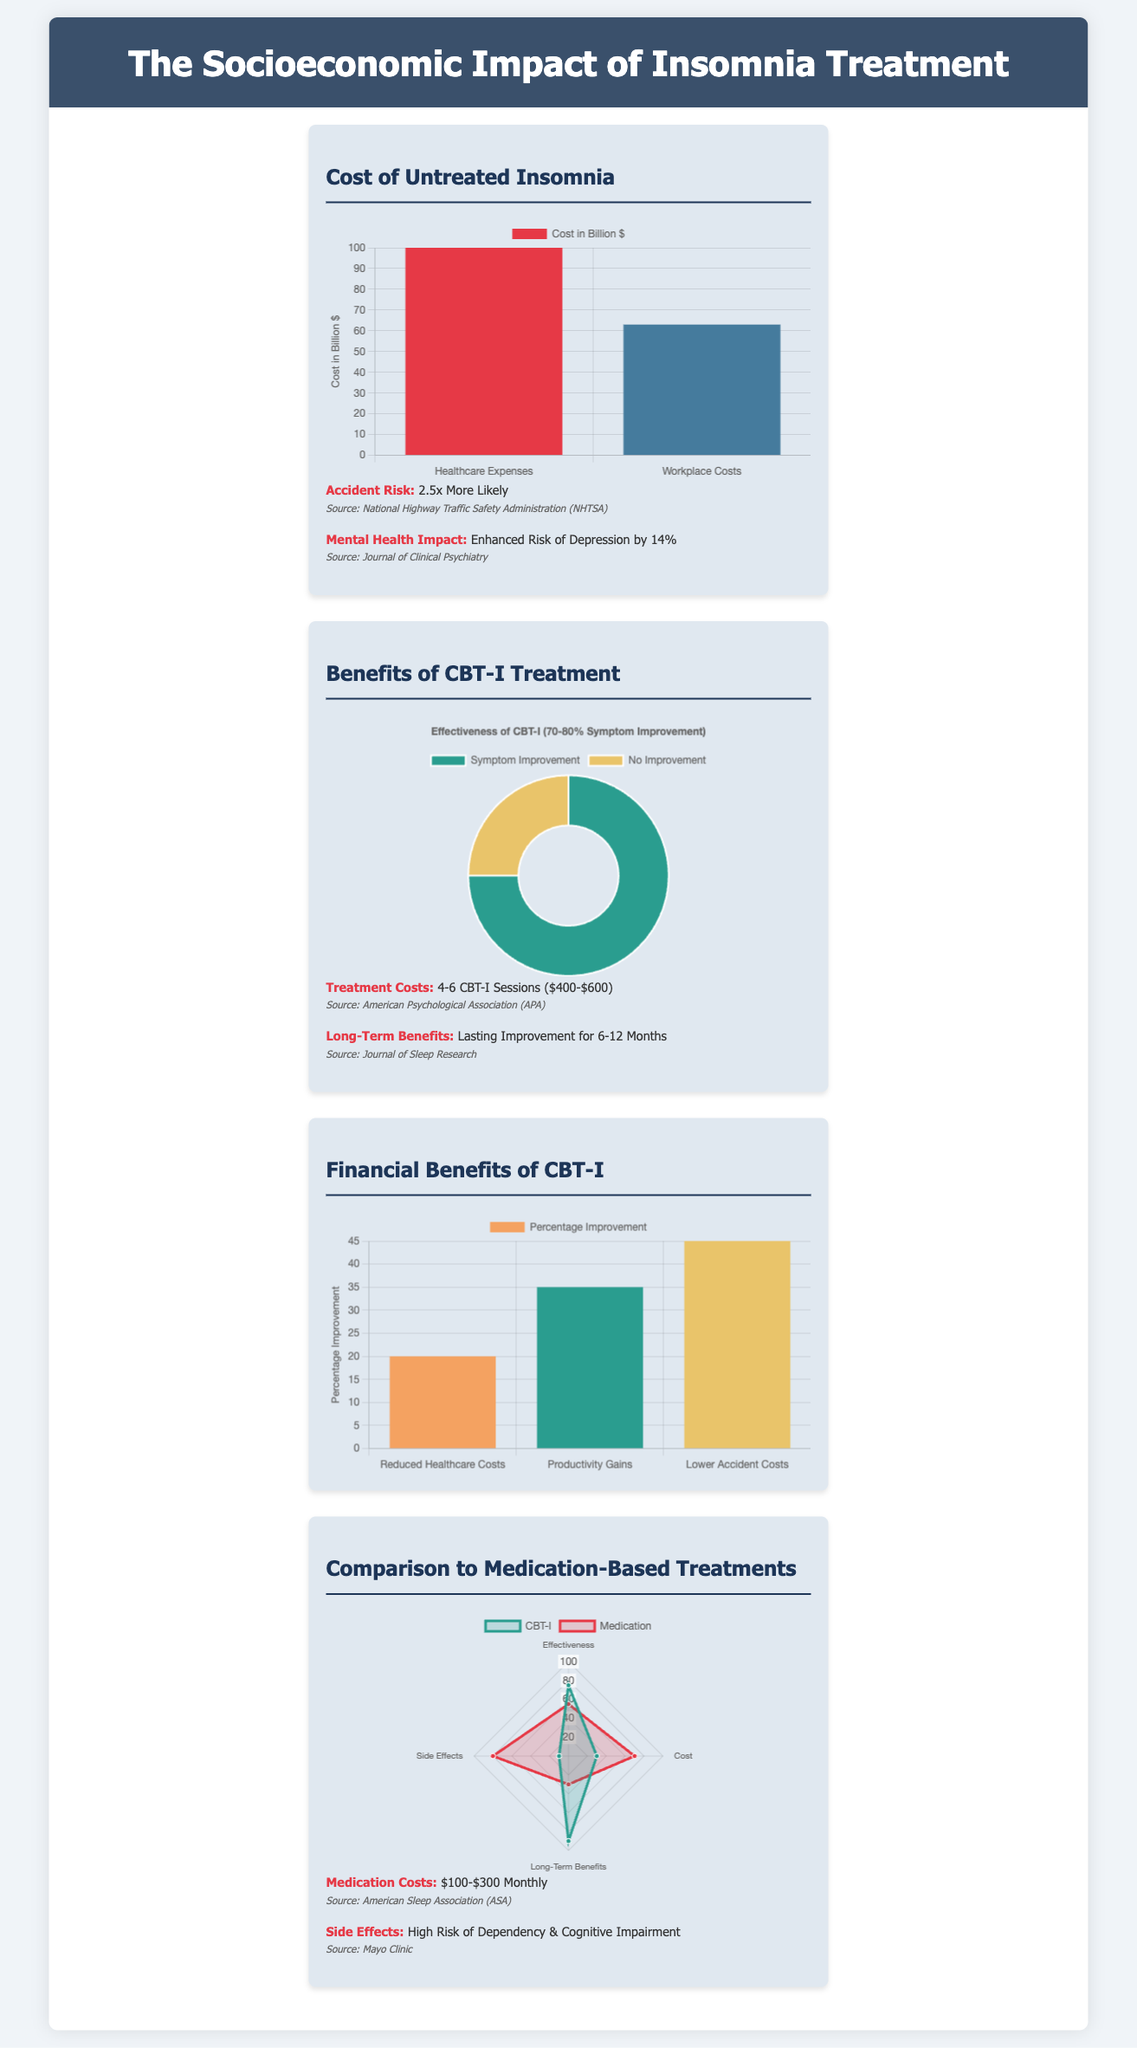What is the cost of untreated insomnia in healthcare expenses? The document states that the cost of untreated insomnia in healthcare expenses is 100 billion dollars.
Answer: 100 billion dollars How many CBT-I sessions are typically required for treatment? The document mentions that treatment typically requires 4-6 CBT-I sessions.
Answer: 4-6 sessions What percentage of patients experience symptom improvement with CBT-I? According to the infographic, 70-80% of patients experience symptom improvement with CBT-I.
Answer: 70-80% What are the monthly medication costs mentioned? The document presents that the monthly medication costs range from 100 to 300 dollars.
Answer: 100-300 dollars What is the percentage of productivity gain attributed to CBT-I treatment? The financial benefits chart indicates a 35% productivity gain attributed to CBT-I treatment.
Answer: 35% How does the effectiveness of CBT-I compare to medication in terms of long-term benefits? The comparison shows that CBT-I has a 90% rating for long-term benefits, whereas medication has a 30% rating.
Answer: 90% (CBT-I), 30% (medication) What is the risk increase for accidents associated with untreated insomnia? The document states that individuals with untreated insomnia are 2.5 times more likely to have accidents.
Answer: 2.5 times What is a significant side effect of medication-based treatments for insomnia? The document notes that a high risk of dependency & cognitive impairment is a significant side effect.
Answer: High risk of dependency & cognitive impairment How long do the long-term benefits of CBT-I last? The document mentions that long-term benefits of CBT-I can last for 6-12 months.
Answer: 6-12 months 